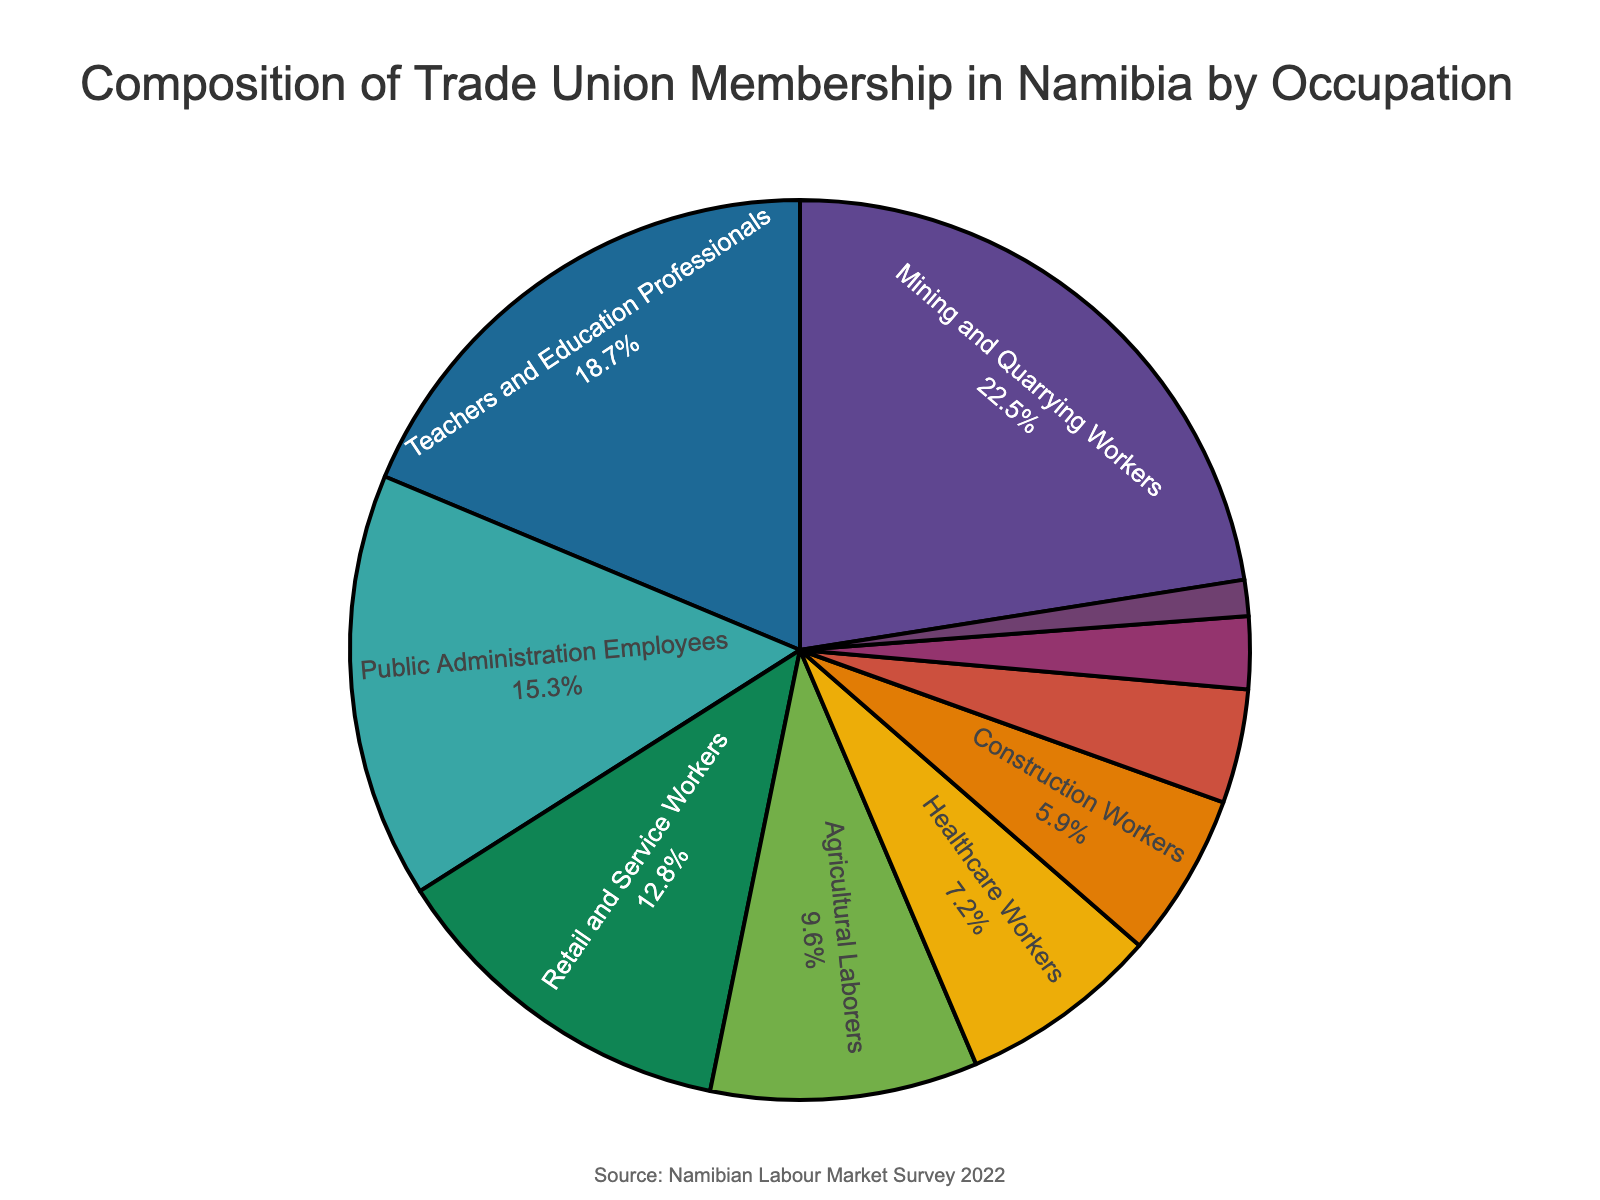Which occupation has the largest percentage of trade union membership? Look at the pie chart and identify the segment with the largest size; it is usually labeled for easier identification. Here, the largest segment is labeled as "Mining and Quarrying Workers".
Answer: Mining and Quarrying Workers What is the combined percentage of trade union membership for Teachers and Healthcare Workers? Sum the percentages of "Teachers and Education Professionals" and "Healthcare Workers". 18.7% + 7.2% = 25.9%
Answer: 25.9% Which two occupations have the smallest percentages of trade union membership? Identify the two smallest segments of the pie chart by comparing the sizes of all segments. The smallest segments are labeled as "Hospitality and Tourism Staff" and "Manufacturing Workers".
Answer: Hospitality and Tourism Staff and Manufacturing Workers How much more percentage of trade union membership do Public Administration Employees have compared to Construction Workers? Subtract the percentage of Construction Workers from the percentage of Public Administration Employees. 15.3% - 5.9% = 9.4%
Answer: 9.4% Which occupational group constitutes less than 5% of the trade union membership? Find the segment with a percentage less than 5%. The "Transport and Logistics Employees" group constitutes 4.1%, which is less than 5%.
Answer: Transport and Logistics Employees What percentage of trade union membership is represented by Mining and Quarrying Workers and Teachers combined? Add the percentages of "Mining and Quarrying Workers" (22.5%) and "Teachers and Education Professionals" (18.7%). 22.5% + 18.7% = 41.2%
Answer: 41.2% How do the percentages of Agricultural Laborers and Retail and Service Workers compare? Compare the percentages directly from the chart. Agricultural Laborers have 9.6% while Retail and Service Workers have 12.8%. Retail and Service Workers have a higher percentage.
Answer: Retail and Service Workers have a higher percentage What visual elements help identify the Public Administration Employees segment in the pie chart? The segment's size, label position, and color differentiate it from others. The Public Administration Employees segment has a noticeable size, label inside the segment, and unique color based on the palette.
Answer: Size, label, and color What is the difference in trade union membership percentage between Transport and Logistics Employees and Healthcare Workers? Subtract the percentage of Transport and Logistics Employees from Healthcare Workers. 7.2% - 4.1% = 3.1%
Answer: 3.1% Is the percentage of Construction Workers in trade unions higher or lower than that of Agricultural Laborers? Compare the percentages of Construction Workers (5.9%) and Agricultural Laborers (9.6%). Construction Workers have a lower percentage.
Answer: Lower 